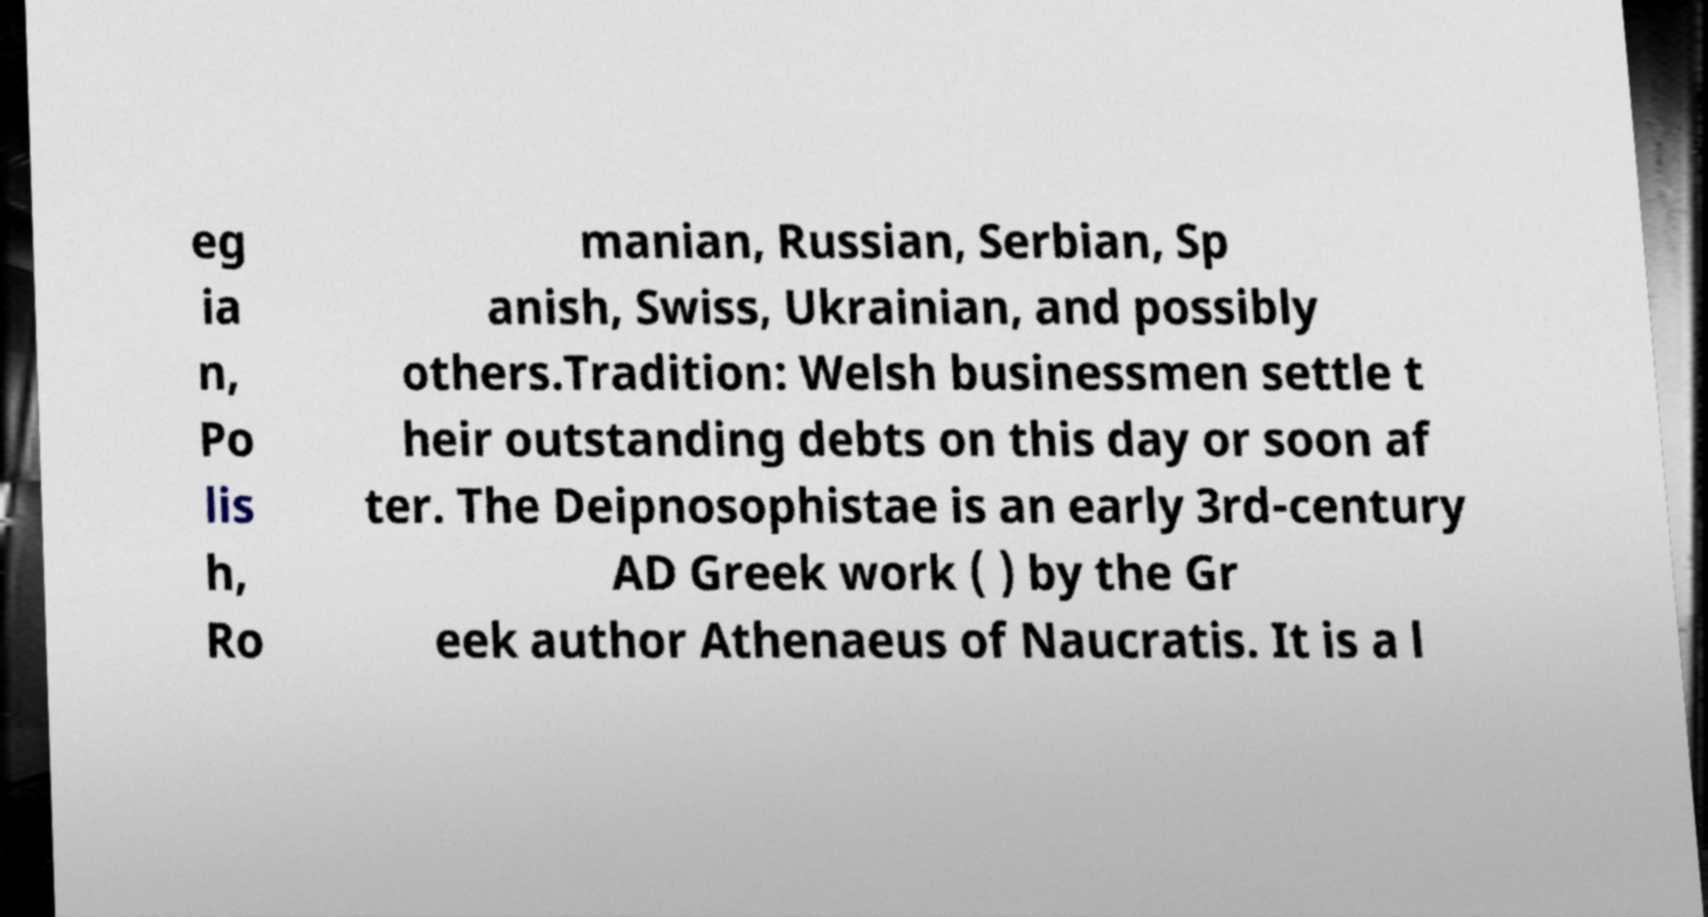Could you assist in decoding the text presented in this image and type it out clearly? eg ia n, Po lis h, Ro manian, Russian, Serbian, Sp anish, Swiss, Ukrainian, and possibly others.Tradition: Welsh businessmen settle t heir outstanding debts on this day or soon af ter. The Deipnosophistae is an early 3rd-century AD Greek work ( ) by the Gr eek author Athenaeus of Naucratis. It is a l 